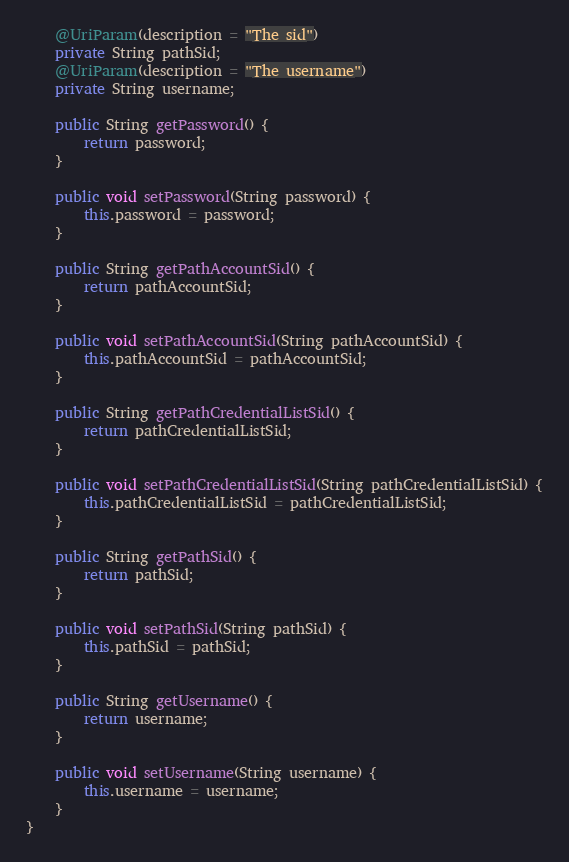<code> <loc_0><loc_0><loc_500><loc_500><_Java_>    @UriParam(description = "The sid")
    private String pathSid;
    @UriParam(description = "The username")
    private String username;

    public String getPassword() {
        return password;
    }

    public void setPassword(String password) {
        this.password = password;
    }

    public String getPathAccountSid() {
        return pathAccountSid;
    }

    public void setPathAccountSid(String pathAccountSid) {
        this.pathAccountSid = pathAccountSid;
    }

    public String getPathCredentialListSid() {
        return pathCredentialListSid;
    }

    public void setPathCredentialListSid(String pathCredentialListSid) {
        this.pathCredentialListSid = pathCredentialListSid;
    }

    public String getPathSid() {
        return pathSid;
    }

    public void setPathSid(String pathSid) {
        this.pathSid = pathSid;
    }

    public String getUsername() {
        return username;
    }

    public void setUsername(String username) {
        this.username = username;
    }
}
</code> 